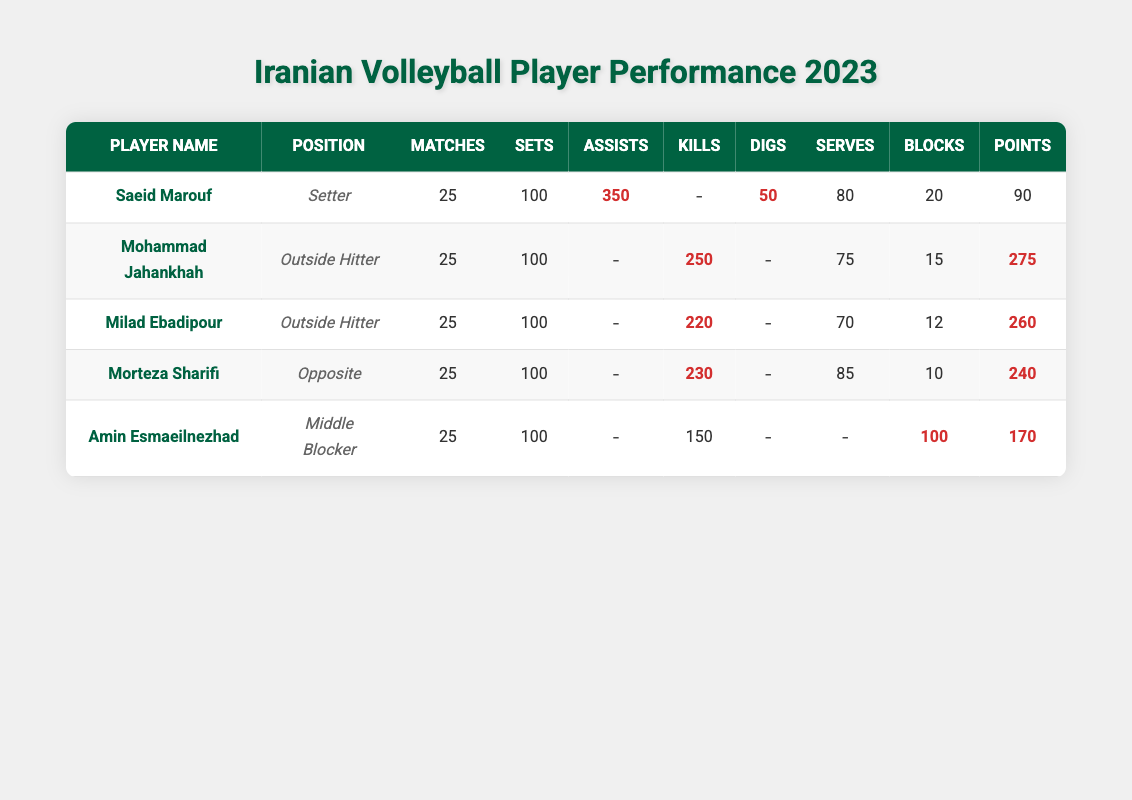What is the total number of kills made by Mohammad Jahankhah and Morteza Sharifi? Mohammad Jahankhah made 250 kills and Morteza Sharifi made 230 kills. Adding these together: 250 + 230 = 480.
Answer: 480 Which player has the highest number of assists? The highest number of assists is 350, achieved by Saeid Marouf.
Answer: Saeid Marouf How many players have recorded 100 or more blocks this season? Only one player, Amin Esmaeilnezhad, has recorded 100 blocks this season.
Answer: 1 What percentage of Saeid Marouf's total matches did he play as a Setter? Saeid Marouf played 25 matches, and since he played all of them as a Setter, the percentage is (25/25) * 100 = 100%.
Answer: 100% Which player's performance in points is closest to the average points of the team? The players have the following points: 90, 275, 260, 240, 170. The average is (90 + 275 + 260 + 240 + 170) / 5 = 205. There are two players closest to the average: Milad Ebadipour with 260 and Morteza Sharifi with 240, but Milad Ebadipour is closer since 260 - 205 < 240 - 205.
Answer: Milad Ebadipour Did any player have more errors than blocks? Yes, Mohammad Jahankhah had 35 errors while he had 15 blocks, which means he had more errors than blocks.
Answer: Yes What is the total number of digs recorded by all players? The total number of digs is the sum of the digs by each player: 50 (Saeid) + 0 (Jahankhah) + 0 (Ebadipour) + 0 (Sharifi) + 0 (Esmaeilnezhad) = 50.
Answer: 50 Who scored the least number of points among all players? The least number of points is 90, scored by Saeid Marouf.
Answer: Saeid Marouf What is the combined number of kills by all Outside Hitters? The Outside Hitters are Mohammad Jahankhah with 250 kills and Milad Ebadipour with 220 kills. Adding these gives: 250 + 220 = 470.
Answer: 470 Is there any player who scored 170 points and had 100 blocks? Yes, Amin Esmaeilnezhad scored 170 points and had 100 blocks.
Answer: Yes 